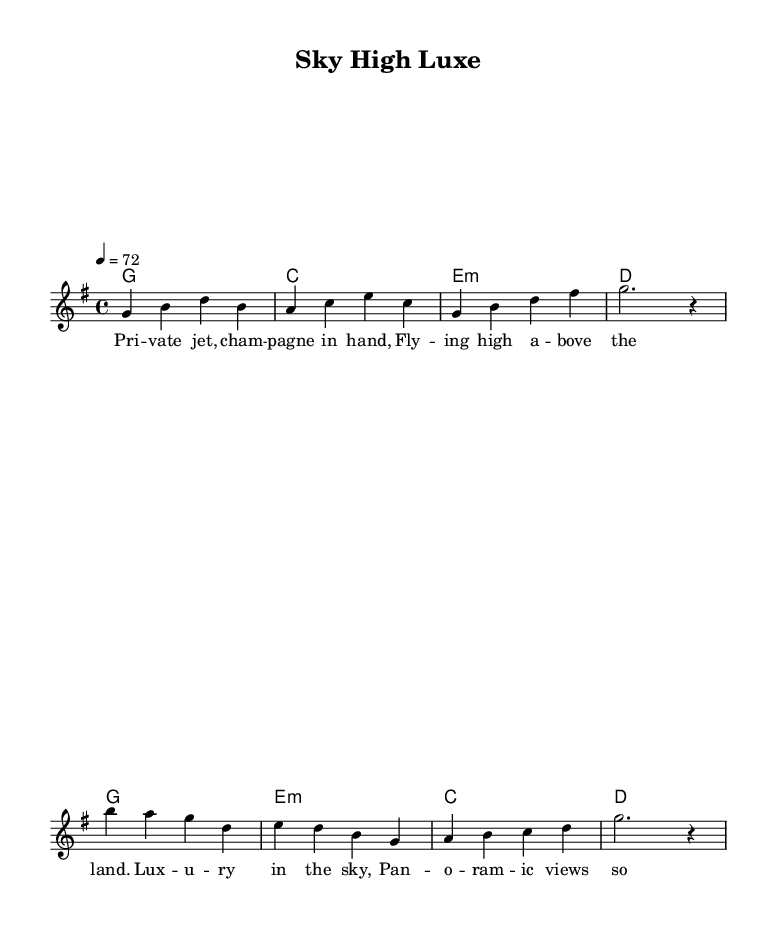What is the key signature of this music? The key signature is G major, which has one sharp (F#). This is indicated at the beginning of the sheet music under the clef.
Answer: G major What is the time signature of this music? The time signature is 4/4, which means there are four beats in each measure and the quarter note gets one beat. This is found at the beginning of the score as well.
Answer: 4/4 What is the tempo marking of this piece? The tempo marking is 72 beats per minute. This is noted at the top of the sheet music, indicating the speed at which the music should be played.
Answer: 72 How many measures are in the verse section? The verse consists of four measures, which can be counted starting from the first bar and going until the end of the verse segment.
Answer: 4 What type of chord follows the G major chord in the verse? Following the G major chord, the next chord is C major in the verse sequence, which is indicated in the harmony section.
Answer: C major What is the theme of the lyrics in this piece? The lyrics focus on luxury and flying high, with references to private jets and panoramic views, suggesting a celebration of lavish lifestyles. This can be inferred from the literal wording of the lyrics.
Answer: Luxury and travel How is the contrast achieved between the verse and the chorus? The contrast is mainly achieved through the different melodic lines and changes in harmony, where the chorus offers a more expansive sound compared to the verse's more grounded vibe, showcasing the luxurious theme.
Answer: Melodic and harmonic contrast 